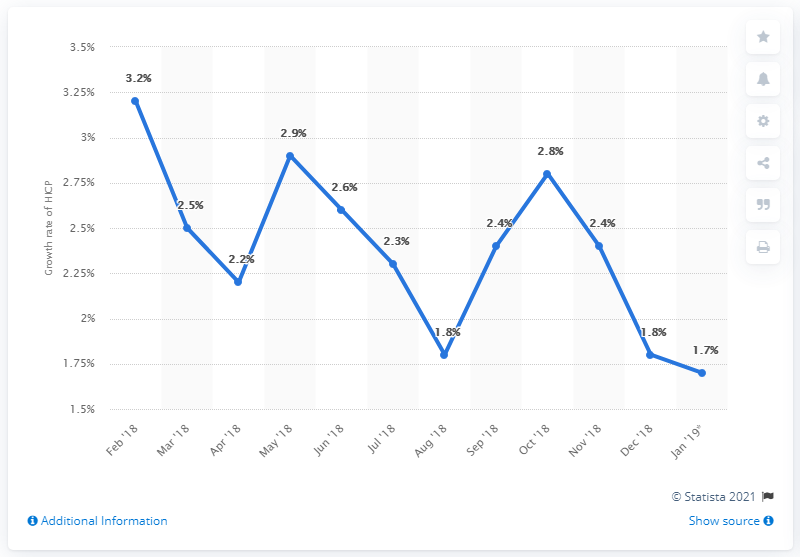Specify some key components in this picture. The inflation rate in December 2018 was 1.8%. The value that was recorded in August 2018 was 1.8. The average of the last four months from October 2018 is 2.175. 